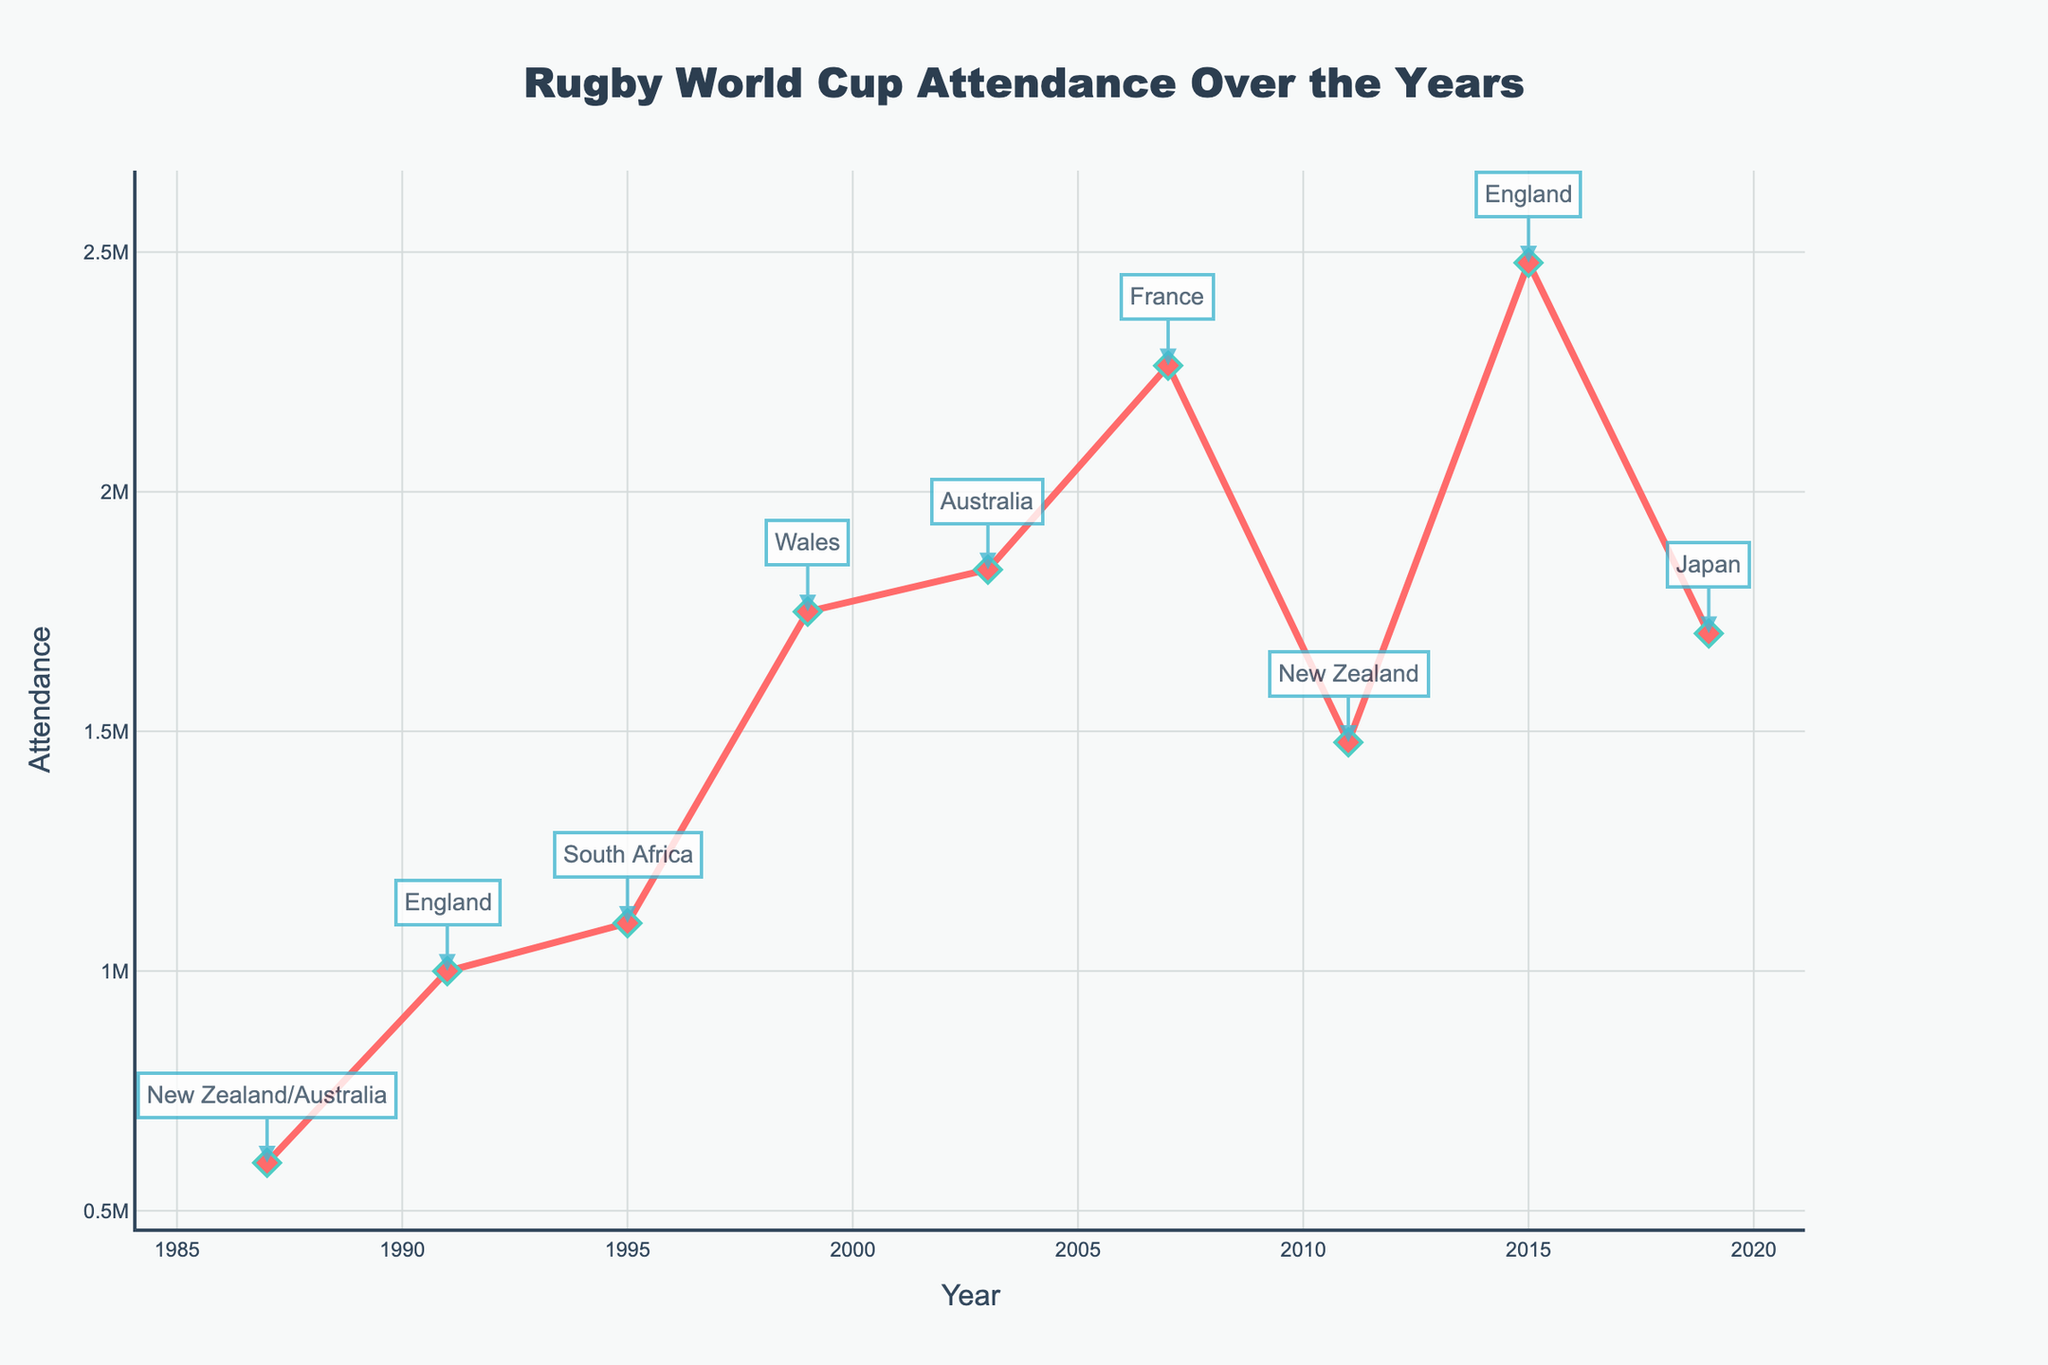Which year had the highest attendance? The year with the highest attendance is identified by looking for the peak in the attendance line on the graph, which corresponds to 2015.
Answer: 2015 How does the attendance in the 1987 World Cup compare to 1991 World Cup? To compare the attendance, observe the initial and the subsequent points. The attendance increased from 600,000 in 1987 to 1,000,000 in 1991.
Answer: 1991 had higher attendance What is the total attendance for the years when the World Cup was hosted by England? Sum the attendance for the years 1991 and 2015, hosted by England. This is 1,000,000 (1991) + 2,477,805 (2015).
Answer: 3,477,805 Between 1999 and 2007, which host country had the highest attendance? Compare the attendance figures: Wales in 1999 had 1,750,000, Australia in 2003 had 1,837,547, and France in 2007 had 2,263,223. France had the highest attendance.
Answer: France What was the attendance trend from 1995 to 2007? Start from the attendance in 1995 (1,100,000), then note the increase in 1999 (1,750,000), 2003 (1,837,547), and then reaching a peak in 2007 (2,263,223). The trend is increasing.
Answer: Increasing How much did the attendance change from 2011 to 2015? Subtract the 2011 attendance (1,477,294) from the 2015 attendance (2,477,805): 2,477,805 - 1,477,294.
Answer: 1,000,511 Compare the attendance for the years 2003 and 2019. Look at the attendance values for 2003 (1,837,547) and 2019 (1,704,443). Notice that 2003 had a slightly higher attendance than 2019.
Answer: 2003 had higher attendance Which year had the lowest attendance and what was the host country? The lowest attendance is identified as the first data point at 600,000, which corresponds to the year 1987 hosted by New Zealand/Australia.
Answer: 1987, New Zealand/Australia What was the average attendance from 1987 to 2003? Calculate the average by summing the attendance for 1987 (600,000), 1991 (1,000,000), 1995 (1,100,000), 1999 (1,750,000), and 2003 (1,837,547) and then divide by 5. (600,000+1,000,000+1,100,000+1,750,000+1,837,547)/5
Answer: 1,257,509 What can you infer about the attendance trend in Rugby World Cups hosted by New Zealand only? Look at the 1987 and 2011 data points where New Zealand was a host. In 1987, it was 600,000 and in 2011 it rose significantly to 1,477,294, showing a large increase.
Answer: Increased 